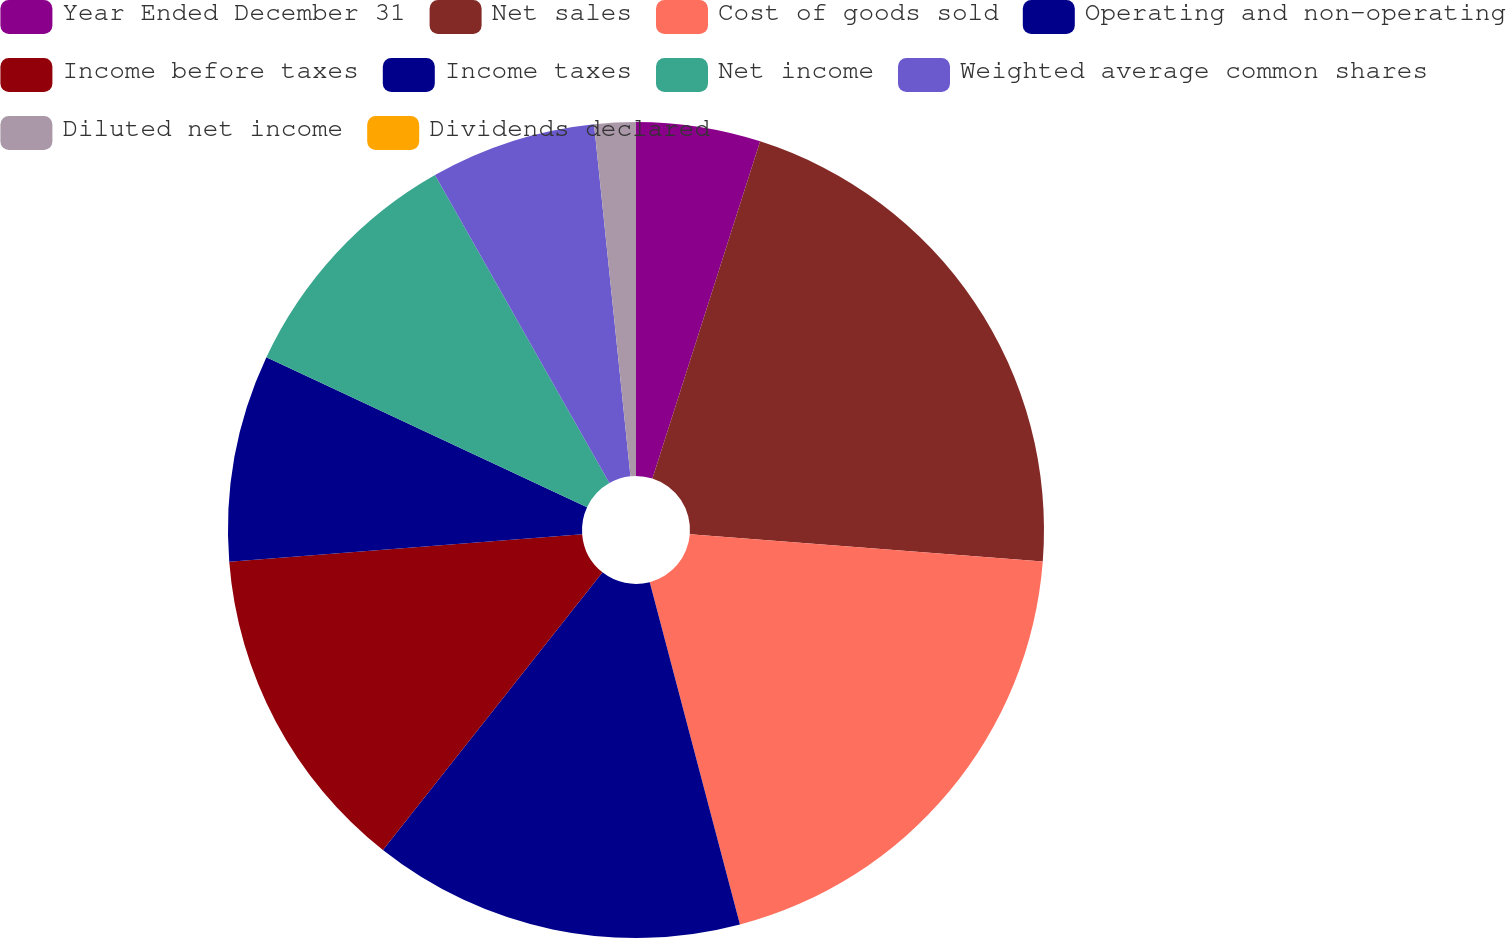Convert chart to OTSL. <chart><loc_0><loc_0><loc_500><loc_500><pie_chart><fcel>Year Ended December 31<fcel>Net sales<fcel>Cost of goods sold<fcel>Operating and non-operating<fcel>Income before taxes<fcel>Income taxes<fcel>Net income<fcel>Weighted average common shares<fcel>Diluted net income<fcel>Dividends declared<nl><fcel>4.92%<fcel>21.31%<fcel>19.67%<fcel>14.75%<fcel>13.11%<fcel>8.2%<fcel>9.84%<fcel>6.56%<fcel>1.64%<fcel>0.0%<nl></chart> 